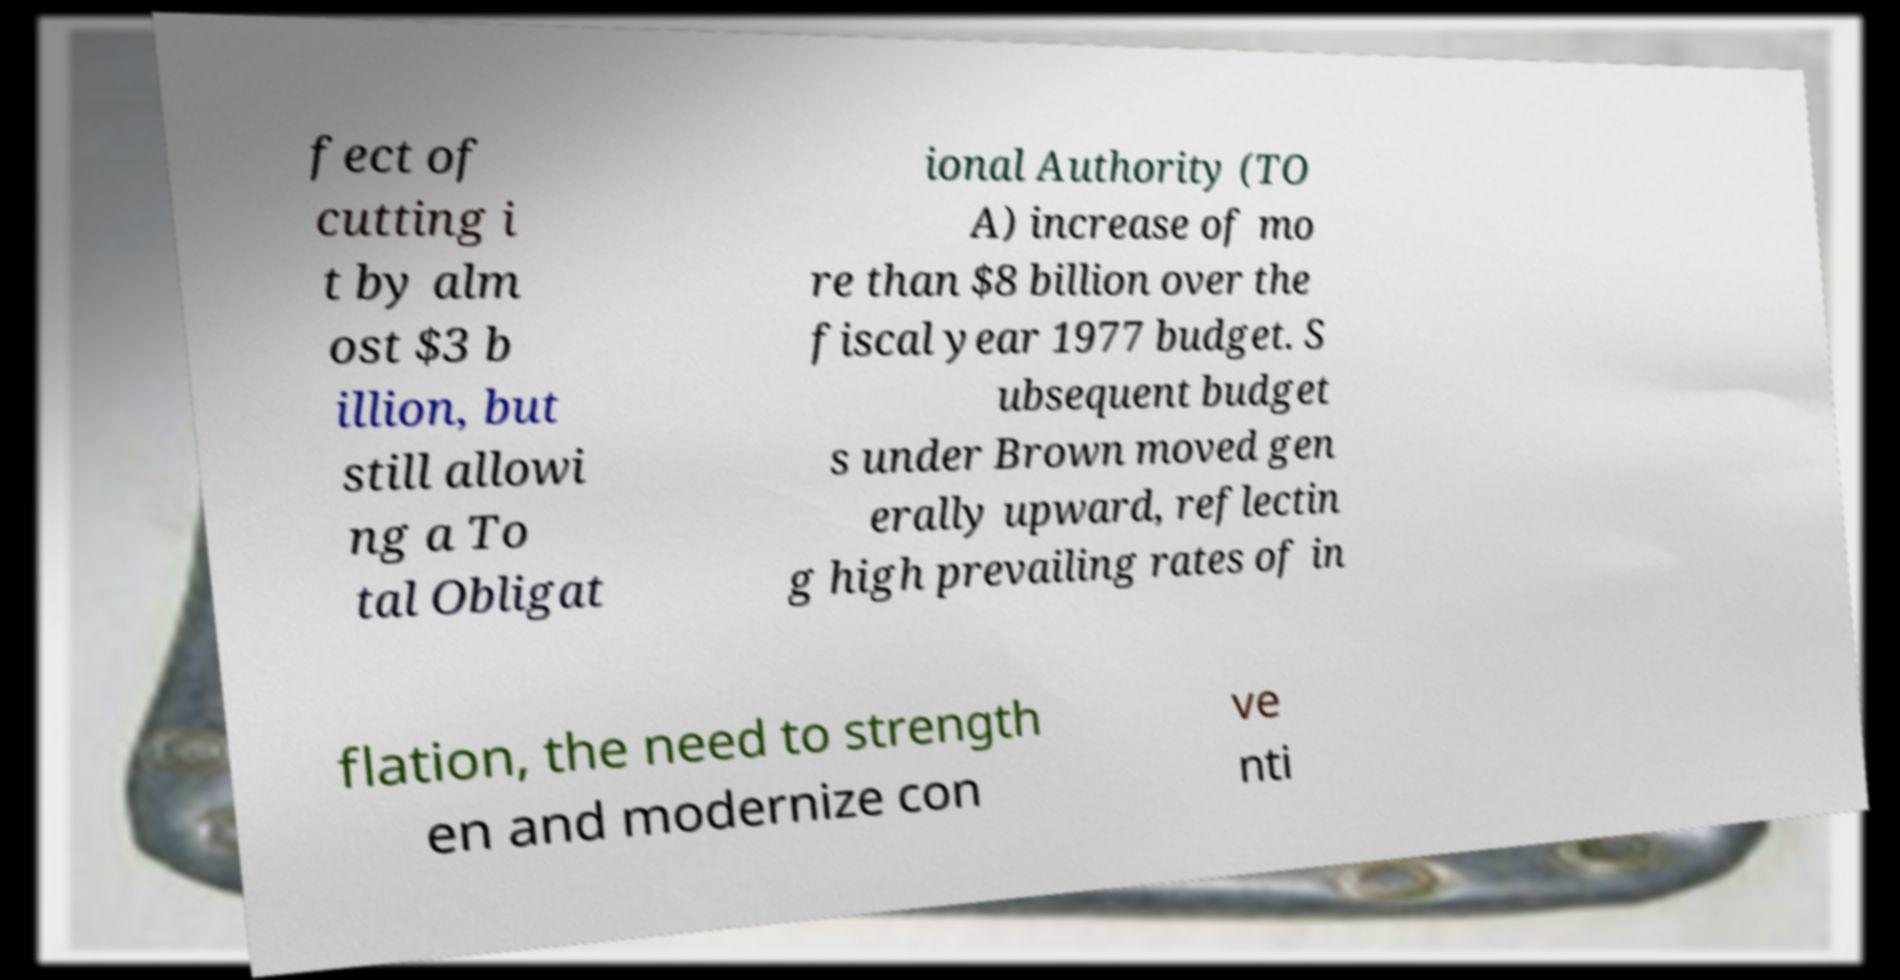There's text embedded in this image that I need extracted. Can you transcribe it verbatim? fect of cutting i t by alm ost $3 b illion, but still allowi ng a To tal Obligat ional Authority (TO A) increase of mo re than $8 billion over the fiscal year 1977 budget. S ubsequent budget s under Brown moved gen erally upward, reflectin g high prevailing rates of in flation, the need to strength en and modernize con ve nti 